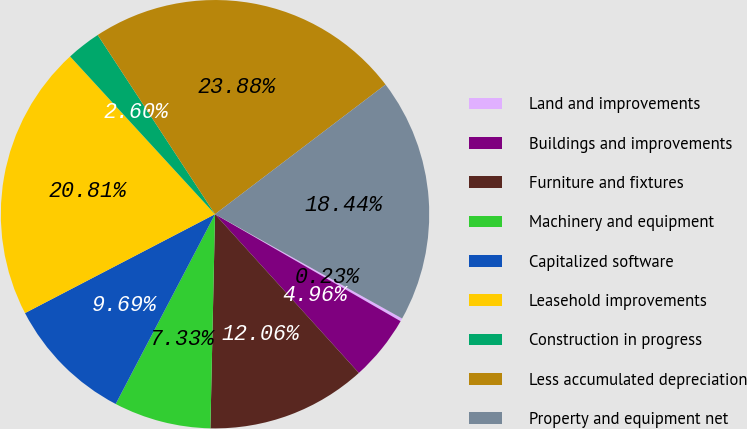Convert chart to OTSL. <chart><loc_0><loc_0><loc_500><loc_500><pie_chart><fcel>Land and improvements<fcel>Buildings and improvements<fcel>Furniture and fixtures<fcel>Machinery and equipment<fcel>Capitalized software<fcel>Leasehold improvements<fcel>Construction in progress<fcel>Less accumulated depreciation<fcel>Property and equipment net<nl><fcel>0.23%<fcel>4.96%<fcel>12.06%<fcel>7.33%<fcel>9.69%<fcel>20.81%<fcel>2.6%<fcel>23.88%<fcel>18.44%<nl></chart> 